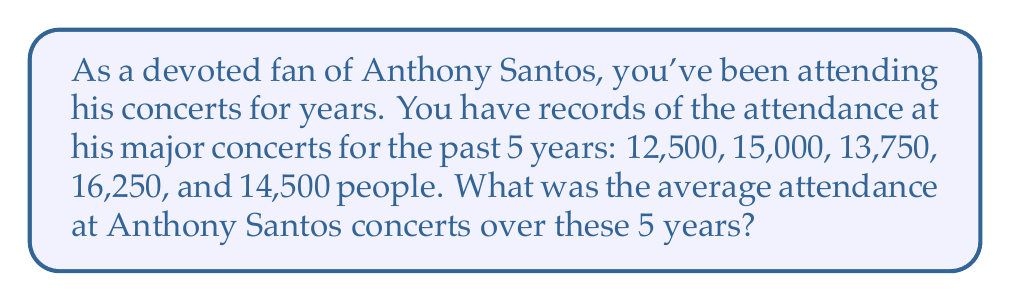Provide a solution to this math problem. To find the average attendance, we need to:

1. Sum up the total attendance for all 5 years
2. Divide the sum by the number of years (5)

Let's break it down step-by-step:

1. Sum of attendances:
   $$12,500 + 15,000 + 13,750 + 16,250 + 14,500 = 72,000$$

2. Calculate the average:
   $$\text{Average} = \frac{\text{Sum of attendances}}{\text{Number of years}}$$
   $$\text{Average} = \frac{72,000}{5} = 14,400$$

Therefore, the average attendance at Anthony Santos concerts over these 5 years was 14,400 people.
Answer: $14,400$ people 